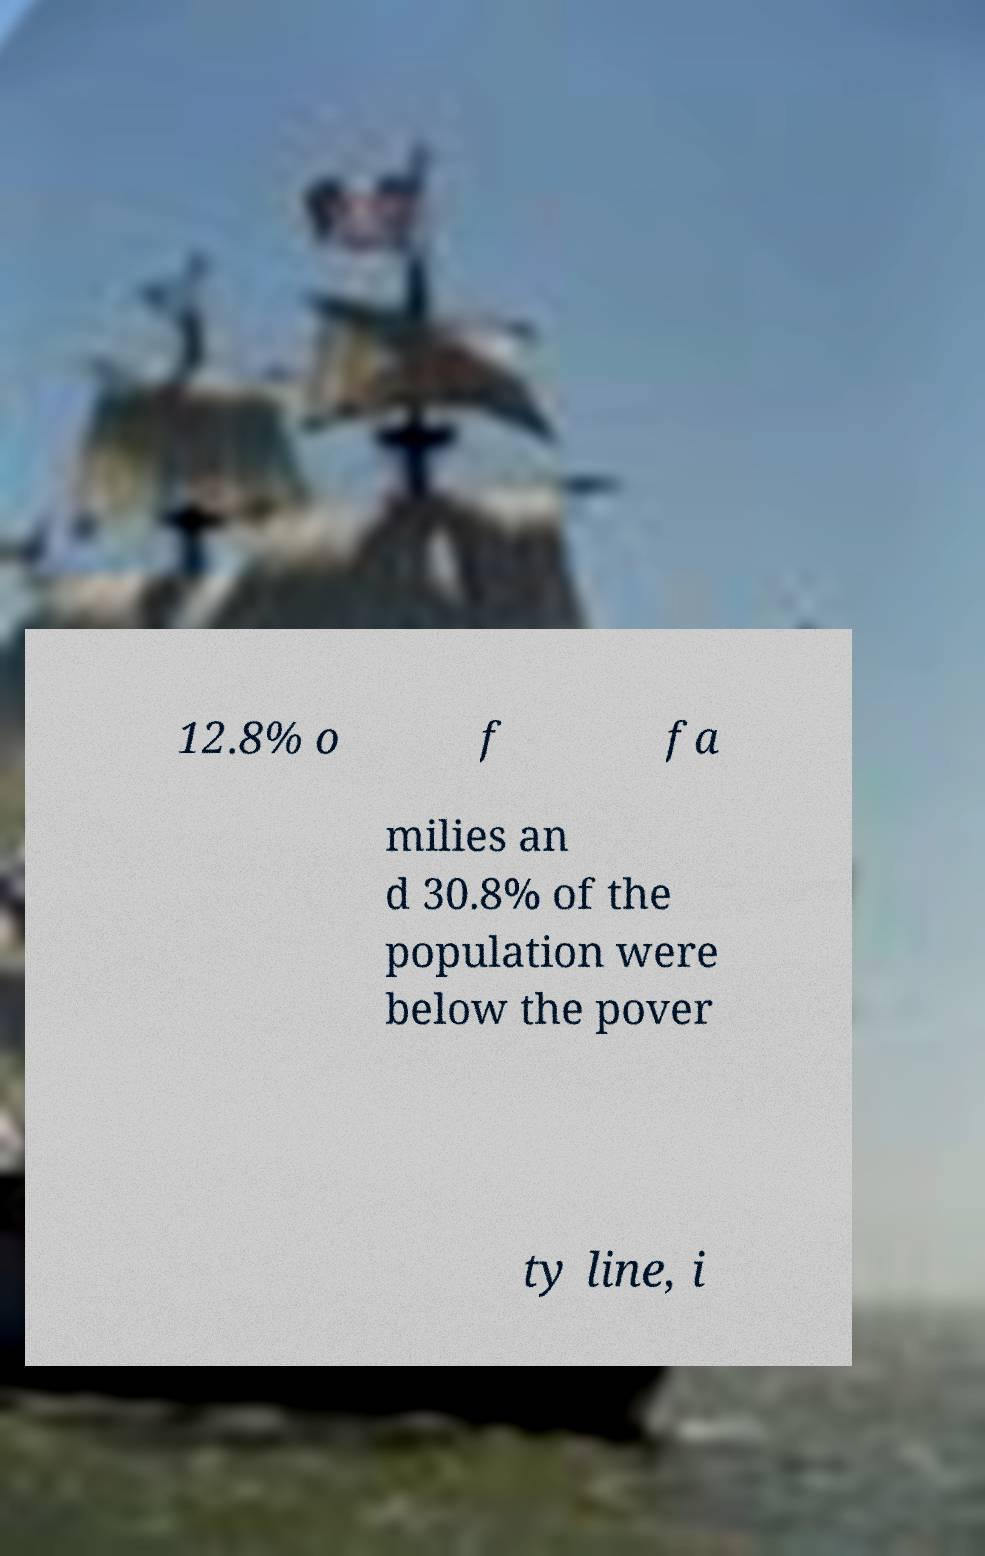I need the written content from this picture converted into text. Can you do that? 12.8% o f fa milies an d 30.8% of the population were below the pover ty line, i 